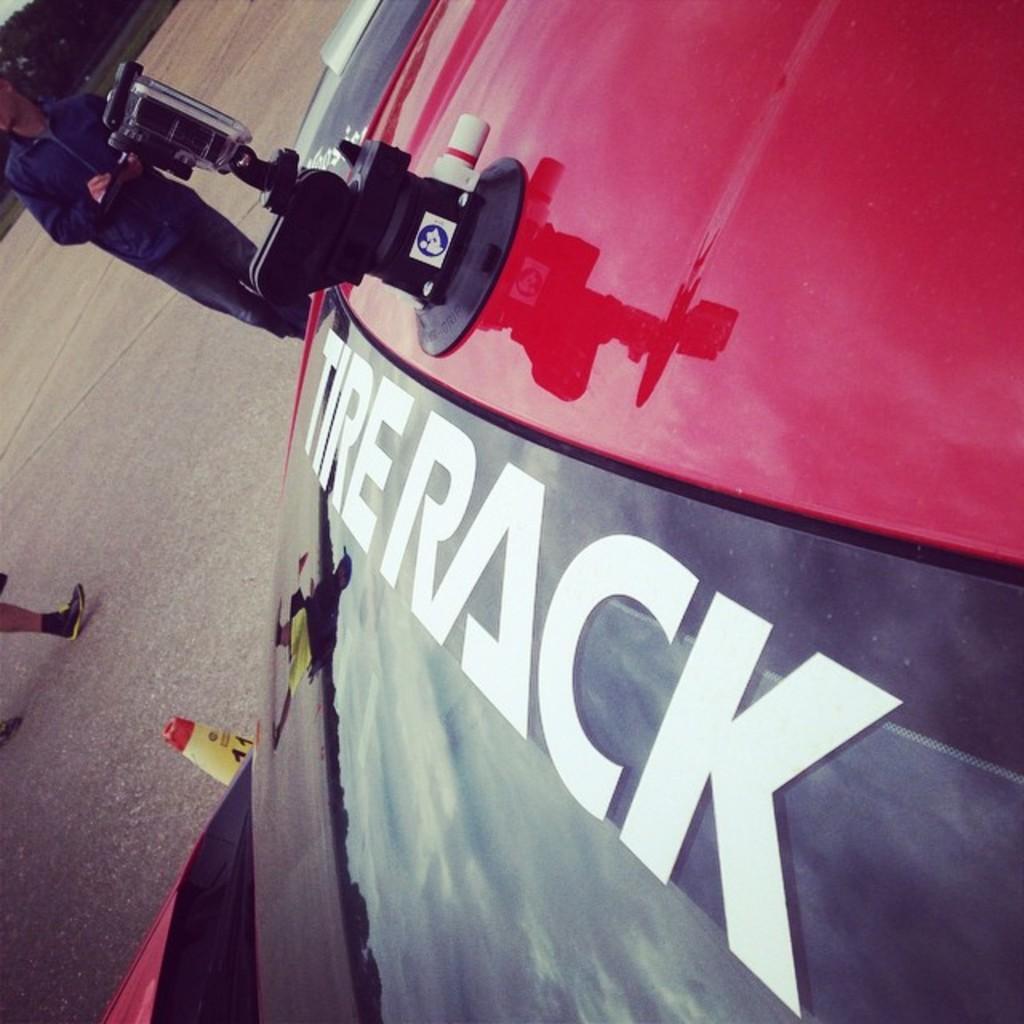Could you give a brief overview of what you see in this image? In this picture, it looks like a vehicle. On the vehicle, there is a camera with a stand. On the left side of the image, there is a person and an object and there are legs of another person. In the top left corner of the image, there are trees and grass. 